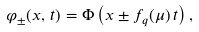Convert formula to latex. <formula><loc_0><loc_0><loc_500><loc_500>\varphi _ { \pm } ( x , \, t ) = \Phi \left ( x \pm f _ { q } ( \mu ) \, t \right ) ,</formula> 